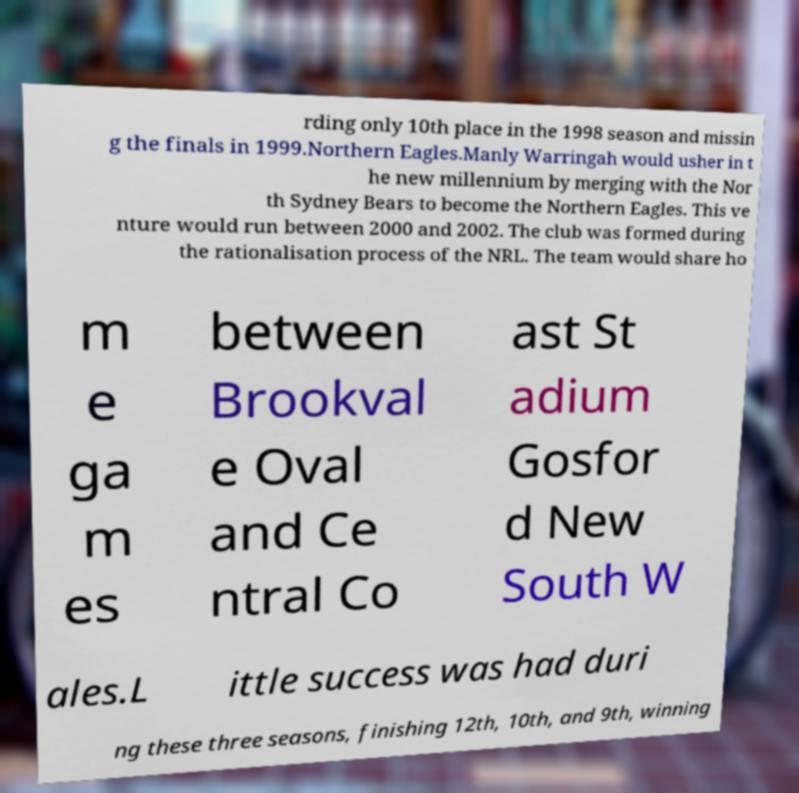Could you extract and type out the text from this image? rding only 10th place in the 1998 season and missin g the finals in 1999.Northern Eagles.Manly Warringah would usher in t he new millennium by merging with the Nor th Sydney Bears to become the Northern Eagles. This ve nture would run between 2000 and 2002. The club was formed during the rationalisation process of the NRL. The team would share ho m e ga m es between Brookval e Oval and Ce ntral Co ast St adium Gosfor d New South W ales.L ittle success was had duri ng these three seasons, finishing 12th, 10th, and 9th, winning 